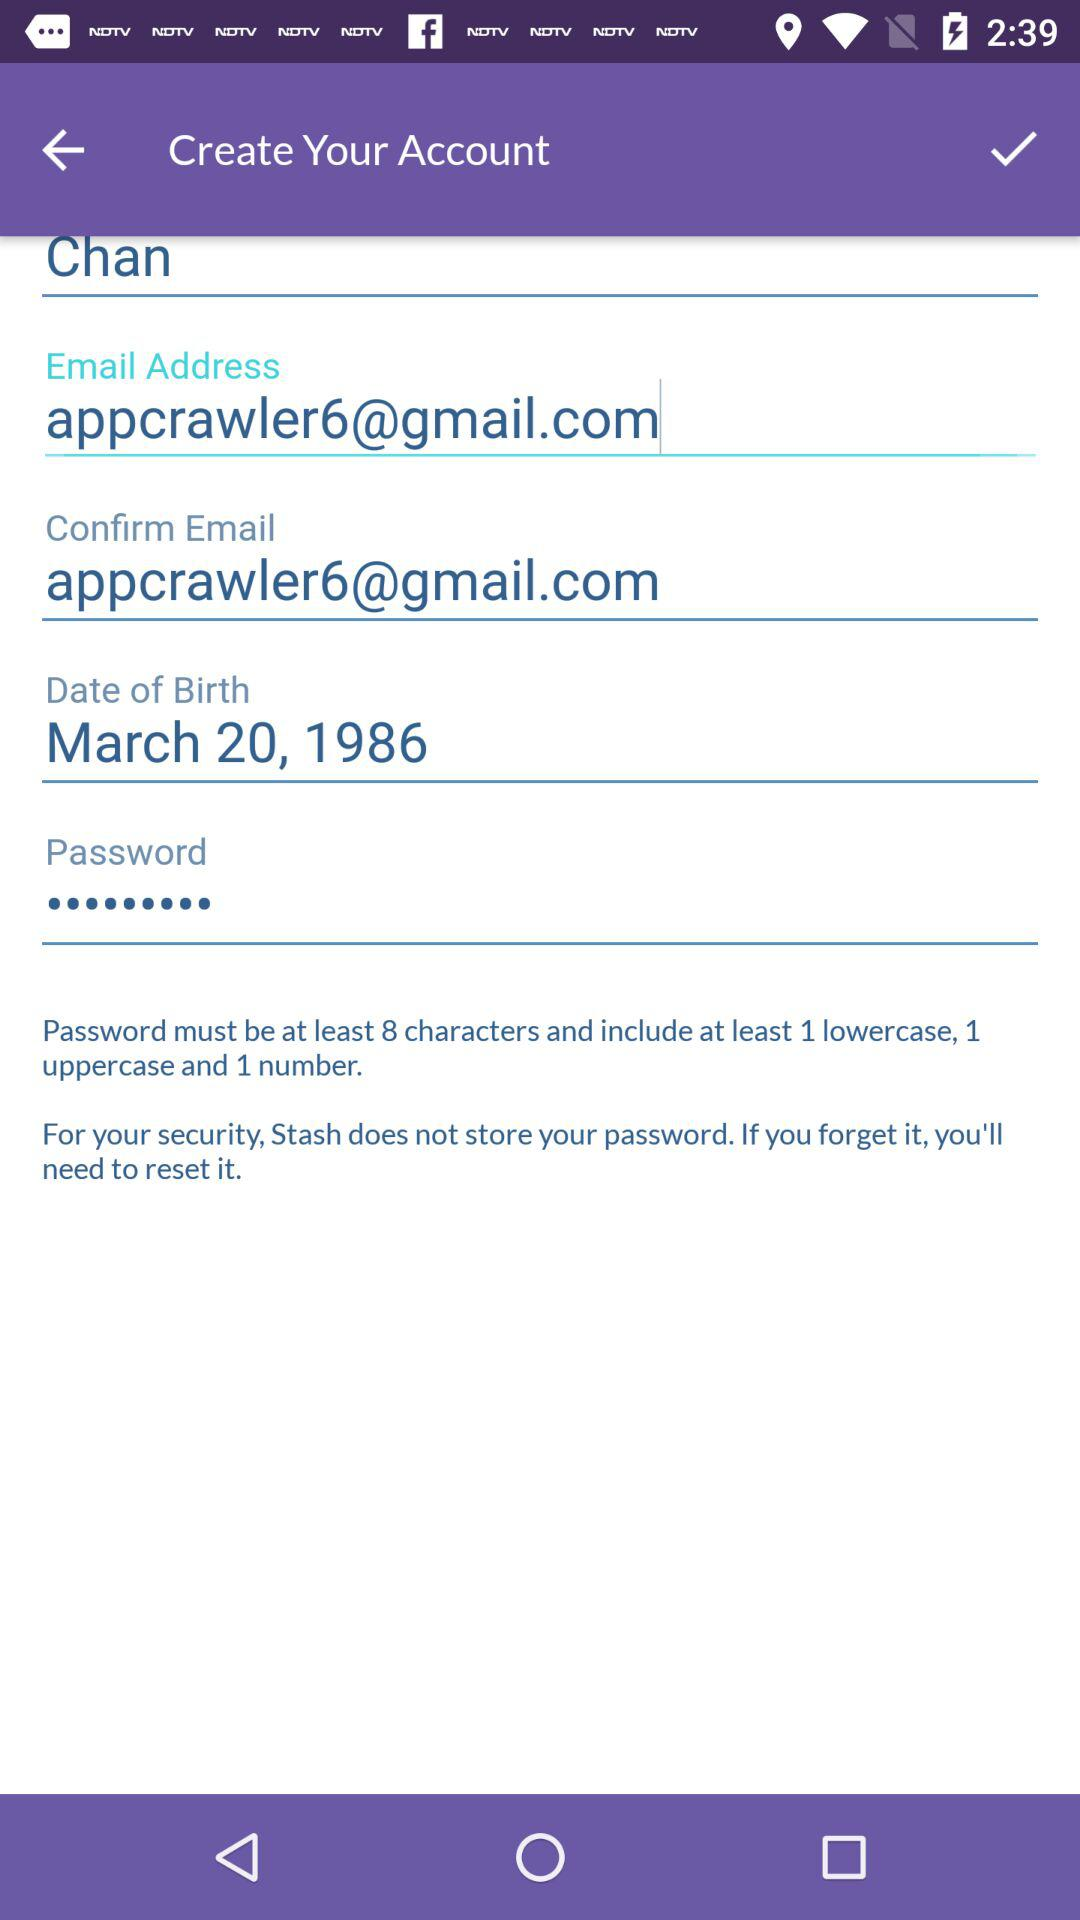What is the email address? The email address is appcrawler6@gmail.com. 